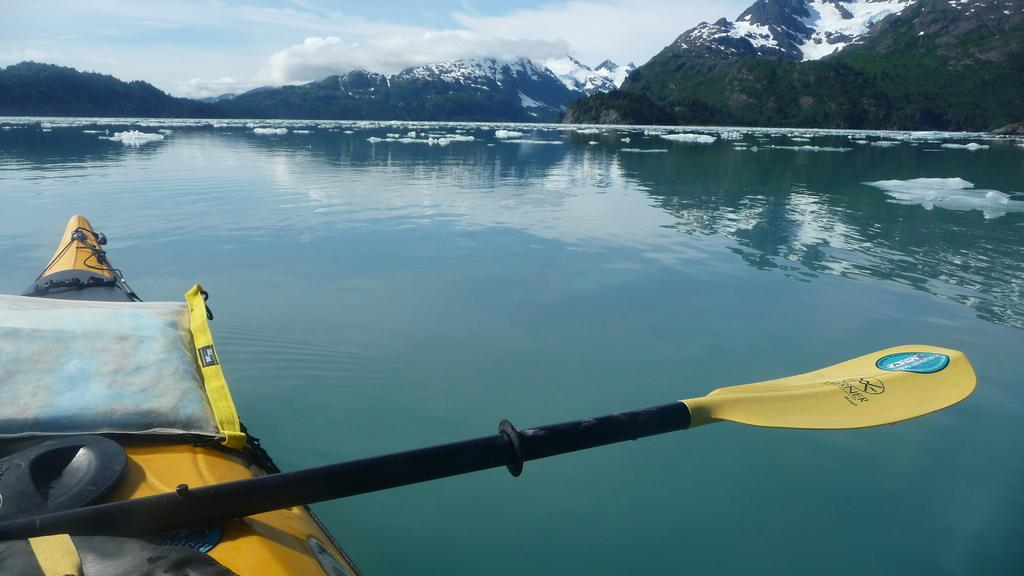What type of natural formation can be seen in the image? There are mountains visible in the image. What part of the natural environment is visible in the image? The sky is visible in the image. What object is used for propulsion in the image? There is a paddle in the image. What type of vehicle is present in the image? There are objects on a boat in the image. Where is the boat located in the image? The boat is on the water surface. What type of wheel can be seen on the boat in the image? There are no wheels present on the boat in the image. What detail can be observed on the paddle in the image? The provided facts do not mention any specific details about the paddle, so we cannot answer this question definitively. 